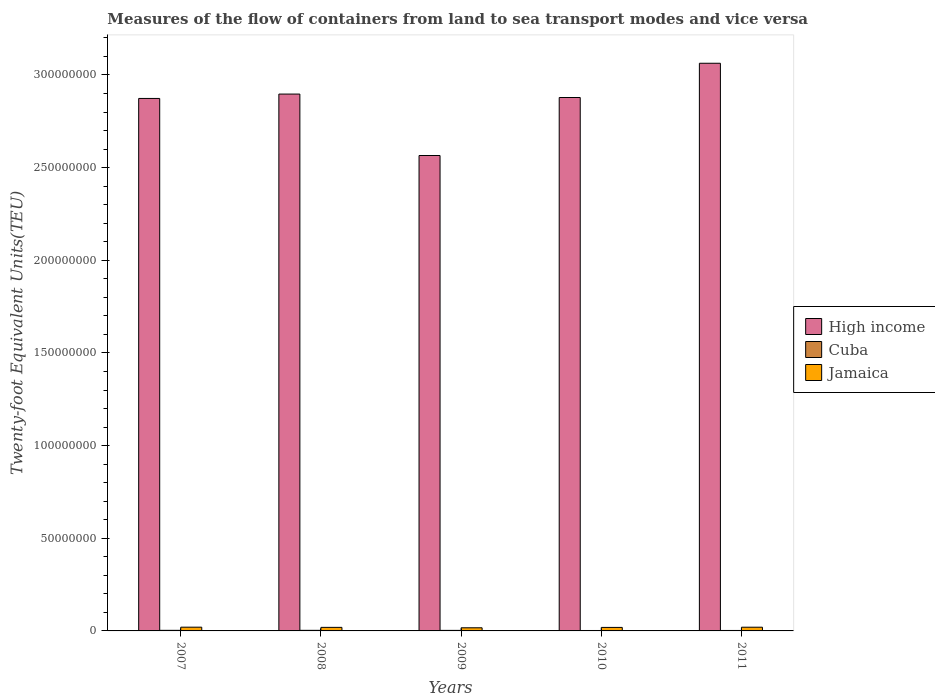How many bars are there on the 1st tick from the left?
Your answer should be very brief. 3. What is the label of the 4th group of bars from the left?
Make the answer very short. 2010. What is the container port traffic in High income in 2011?
Your answer should be compact. 3.06e+08. Across all years, what is the maximum container port traffic in High income?
Provide a succinct answer. 3.06e+08. Across all years, what is the minimum container port traffic in High income?
Make the answer very short. 2.57e+08. In which year was the container port traffic in Cuba maximum?
Offer a terse response. 2007. What is the total container port traffic in Cuba in the graph?
Offer a very short reply. 1.40e+06. What is the difference between the container port traffic in High income in 2007 and that in 2009?
Give a very brief answer. 3.08e+07. What is the difference between the container port traffic in Cuba in 2008 and the container port traffic in Jamaica in 2007?
Provide a succinct answer. -1.70e+06. What is the average container port traffic in Jamaica per year?
Provide a succinct answer. 1.90e+06. In the year 2011, what is the difference between the container port traffic in High income and container port traffic in Jamaica?
Provide a short and direct response. 3.04e+08. In how many years, is the container port traffic in Jamaica greater than 170000000 TEU?
Keep it short and to the point. 0. What is the ratio of the container port traffic in Jamaica in 2008 to that in 2011?
Your response must be concise. 0.96. What is the difference between the highest and the second highest container port traffic in Cuba?
Make the answer very short. 857. What is the difference between the highest and the lowest container port traffic in High income?
Make the answer very short. 4.98e+07. In how many years, is the container port traffic in Cuba greater than the average container port traffic in Cuba taken over all years?
Provide a short and direct response. 3. What does the 1st bar from the left in 2011 represents?
Offer a very short reply. High income. What does the 3rd bar from the right in 2007 represents?
Provide a succinct answer. High income. Is it the case that in every year, the sum of the container port traffic in High income and container port traffic in Jamaica is greater than the container port traffic in Cuba?
Your answer should be compact. Yes. How many bars are there?
Make the answer very short. 15. Does the graph contain grids?
Provide a succinct answer. No. Where does the legend appear in the graph?
Keep it short and to the point. Center right. How many legend labels are there?
Your answer should be very brief. 3. How are the legend labels stacked?
Offer a terse response. Vertical. What is the title of the graph?
Keep it short and to the point. Measures of the flow of containers from land to sea transport modes and vice versa. Does "Senegal" appear as one of the legend labels in the graph?
Offer a terse response. No. What is the label or title of the X-axis?
Your answer should be compact. Years. What is the label or title of the Y-axis?
Offer a terse response. Twenty-foot Equivalent Units(TEU). What is the Twenty-foot Equivalent Units(TEU) in High income in 2007?
Keep it short and to the point. 2.87e+08. What is the Twenty-foot Equivalent Units(TEU) of Cuba in 2007?
Provide a short and direct response. 3.20e+05. What is the Twenty-foot Equivalent Units(TEU) in Jamaica in 2007?
Offer a terse response. 2.02e+06. What is the Twenty-foot Equivalent Units(TEU) of High income in 2008?
Provide a short and direct response. 2.90e+08. What is the Twenty-foot Equivalent Units(TEU) in Cuba in 2008?
Your answer should be compact. 3.19e+05. What is the Twenty-foot Equivalent Units(TEU) of Jamaica in 2008?
Your response must be concise. 1.92e+06. What is the Twenty-foot Equivalent Units(TEU) in High income in 2009?
Keep it short and to the point. 2.57e+08. What is the Twenty-foot Equivalent Units(TEU) in Cuba in 2009?
Your answer should be compact. 2.90e+05. What is the Twenty-foot Equivalent Units(TEU) of Jamaica in 2009?
Ensure brevity in your answer.  1.69e+06. What is the Twenty-foot Equivalent Units(TEU) in High income in 2010?
Give a very brief answer. 2.88e+08. What is the Twenty-foot Equivalent Units(TEU) in Cuba in 2010?
Offer a very short reply. 2.28e+05. What is the Twenty-foot Equivalent Units(TEU) in Jamaica in 2010?
Ensure brevity in your answer.  1.89e+06. What is the Twenty-foot Equivalent Units(TEU) of High income in 2011?
Offer a very short reply. 3.06e+08. What is the Twenty-foot Equivalent Units(TEU) in Cuba in 2011?
Keep it short and to the point. 2.47e+05. What is the Twenty-foot Equivalent Units(TEU) in Jamaica in 2011?
Offer a very short reply. 2.00e+06. Across all years, what is the maximum Twenty-foot Equivalent Units(TEU) of High income?
Give a very brief answer. 3.06e+08. Across all years, what is the maximum Twenty-foot Equivalent Units(TEU) in Cuba?
Make the answer very short. 3.20e+05. Across all years, what is the maximum Twenty-foot Equivalent Units(TEU) in Jamaica?
Make the answer very short. 2.02e+06. Across all years, what is the minimum Twenty-foot Equivalent Units(TEU) in High income?
Provide a succinct answer. 2.57e+08. Across all years, what is the minimum Twenty-foot Equivalent Units(TEU) of Cuba?
Provide a short and direct response. 2.28e+05. Across all years, what is the minimum Twenty-foot Equivalent Units(TEU) of Jamaica?
Keep it short and to the point. 1.69e+06. What is the total Twenty-foot Equivalent Units(TEU) of High income in the graph?
Give a very brief answer. 1.43e+09. What is the total Twenty-foot Equivalent Units(TEU) of Cuba in the graph?
Keep it short and to the point. 1.40e+06. What is the total Twenty-foot Equivalent Units(TEU) of Jamaica in the graph?
Ensure brevity in your answer.  9.51e+06. What is the difference between the Twenty-foot Equivalent Units(TEU) in High income in 2007 and that in 2008?
Your answer should be compact. -2.36e+06. What is the difference between the Twenty-foot Equivalent Units(TEU) of Cuba in 2007 and that in 2008?
Provide a short and direct response. 857. What is the difference between the Twenty-foot Equivalent Units(TEU) of Jamaica in 2007 and that in 2008?
Your answer should be compact. 1.01e+05. What is the difference between the Twenty-foot Equivalent Units(TEU) of High income in 2007 and that in 2009?
Give a very brief answer. 3.08e+07. What is the difference between the Twenty-foot Equivalent Units(TEU) in Cuba in 2007 and that in 2009?
Your answer should be very brief. 2.98e+04. What is the difference between the Twenty-foot Equivalent Units(TEU) in Jamaica in 2007 and that in 2009?
Provide a succinct answer. 3.27e+05. What is the difference between the Twenty-foot Equivalent Units(TEU) of High income in 2007 and that in 2010?
Keep it short and to the point. -5.10e+05. What is the difference between the Twenty-foot Equivalent Units(TEU) of Cuba in 2007 and that in 2010?
Offer a very short reply. 9.15e+04. What is the difference between the Twenty-foot Equivalent Units(TEU) of Jamaica in 2007 and that in 2010?
Your answer should be very brief. 1.25e+05. What is the difference between the Twenty-foot Equivalent Units(TEU) in High income in 2007 and that in 2011?
Your response must be concise. -1.90e+07. What is the difference between the Twenty-foot Equivalent Units(TEU) in Cuba in 2007 and that in 2011?
Provide a succinct answer. 7.31e+04. What is the difference between the Twenty-foot Equivalent Units(TEU) of Jamaica in 2007 and that in 2011?
Make the answer very short. 1.72e+04. What is the difference between the Twenty-foot Equivalent Units(TEU) of High income in 2008 and that in 2009?
Keep it short and to the point. 3.32e+07. What is the difference between the Twenty-foot Equivalent Units(TEU) of Cuba in 2008 and that in 2009?
Keep it short and to the point. 2.89e+04. What is the difference between the Twenty-foot Equivalent Units(TEU) of Jamaica in 2008 and that in 2009?
Provide a succinct answer. 2.26e+05. What is the difference between the Twenty-foot Equivalent Units(TEU) in High income in 2008 and that in 2010?
Offer a very short reply. 1.85e+06. What is the difference between the Twenty-foot Equivalent Units(TEU) of Cuba in 2008 and that in 2010?
Provide a short and direct response. 9.07e+04. What is the difference between the Twenty-foot Equivalent Units(TEU) in Jamaica in 2008 and that in 2010?
Your answer should be very brief. 2.42e+04. What is the difference between the Twenty-foot Equivalent Units(TEU) in High income in 2008 and that in 2011?
Ensure brevity in your answer.  -1.66e+07. What is the difference between the Twenty-foot Equivalent Units(TEU) of Cuba in 2008 and that in 2011?
Provide a short and direct response. 7.22e+04. What is the difference between the Twenty-foot Equivalent Units(TEU) in Jamaica in 2008 and that in 2011?
Your answer should be very brief. -8.37e+04. What is the difference between the Twenty-foot Equivalent Units(TEU) of High income in 2009 and that in 2010?
Offer a very short reply. -3.13e+07. What is the difference between the Twenty-foot Equivalent Units(TEU) of Cuba in 2009 and that in 2010?
Your answer should be compact. 6.18e+04. What is the difference between the Twenty-foot Equivalent Units(TEU) in Jamaica in 2009 and that in 2010?
Make the answer very short. -2.02e+05. What is the difference between the Twenty-foot Equivalent Units(TEU) of High income in 2009 and that in 2011?
Your answer should be very brief. -4.98e+07. What is the difference between the Twenty-foot Equivalent Units(TEU) of Cuba in 2009 and that in 2011?
Ensure brevity in your answer.  4.33e+04. What is the difference between the Twenty-foot Equivalent Units(TEU) in Jamaica in 2009 and that in 2011?
Make the answer very short. -3.10e+05. What is the difference between the Twenty-foot Equivalent Units(TEU) of High income in 2010 and that in 2011?
Ensure brevity in your answer.  -1.85e+07. What is the difference between the Twenty-foot Equivalent Units(TEU) of Cuba in 2010 and that in 2011?
Your response must be concise. -1.84e+04. What is the difference between the Twenty-foot Equivalent Units(TEU) in Jamaica in 2010 and that in 2011?
Your answer should be compact. -1.08e+05. What is the difference between the Twenty-foot Equivalent Units(TEU) of High income in 2007 and the Twenty-foot Equivalent Units(TEU) of Cuba in 2008?
Give a very brief answer. 2.87e+08. What is the difference between the Twenty-foot Equivalent Units(TEU) of High income in 2007 and the Twenty-foot Equivalent Units(TEU) of Jamaica in 2008?
Ensure brevity in your answer.  2.85e+08. What is the difference between the Twenty-foot Equivalent Units(TEU) of Cuba in 2007 and the Twenty-foot Equivalent Units(TEU) of Jamaica in 2008?
Provide a short and direct response. -1.60e+06. What is the difference between the Twenty-foot Equivalent Units(TEU) in High income in 2007 and the Twenty-foot Equivalent Units(TEU) in Cuba in 2009?
Offer a very short reply. 2.87e+08. What is the difference between the Twenty-foot Equivalent Units(TEU) in High income in 2007 and the Twenty-foot Equivalent Units(TEU) in Jamaica in 2009?
Keep it short and to the point. 2.86e+08. What is the difference between the Twenty-foot Equivalent Units(TEU) in Cuba in 2007 and the Twenty-foot Equivalent Units(TEU) in Jamaica in 2009?
Your answer should be very brief. -1.37e+06. What is the difference between the Twenty-foot Equivalent Units(TEU) of High income in 2007 and the Twenty-foot Equivalent Units(TEU) of Cuba in 2010?
Give a very brief answer. 2.87e+08. What is the difference between the Twenty-foot Equivalent Units(TEU) in High income in 2007 and the Twenty-foot Equivalent Units(TEU) in Jamaica in 2010?
Offer a terse response. 2.85e+08. What is the difference between the Twenty-foot Equivalent Units(TEU) in Cuba in 2007 and the Twenty-foot Equivalent Units(TEU) in Jamaica in 2010?
Make the answer very short. -1.57e+06. What is the difference between the Twenty-foot Equivalent Units(TEU) in High income in 2007 and the Twenty-foot Equivalent Units(TEU) in Cuba in 2011?
Your answer should be compact. 2.87e+08. What is the difference between the Twenty-foot Equivalent Units(TEU) in High income in 2007 and the Twenty-foot Equivalent Units(TEU) in Jamaica in 2011?
Offer a terse response. 2.85e+08. What is the difference between the Twenty-foot Equivalent Units(TEU) of Cuba in 2007 and the Twenty-foot Equivalent Units(TEU) of Jamaica in 2011?
Provide a succinct answer. -1.68e+06. What is the difference between the Twenty-foot Equivalent Units(TEU) in High income in 2008 and the Twenty-foot Equivalent Units(TEU) in Cuba in 2009?
Provide a succinct answer. 2.89e+08. What is the difference between the Twenty-foot Equivalent Units(TEU) in High income in 2008 and the Twenty-foot Equivalent Units(TEU) in Jamaica in 2009?
Offer a terse response. 2.88e+08. What is the difference between the Twenty-foot Equivalent Units(TEU) in Cuba in 2008 and the Twenty-foot Equivalent Units(TEU) in Jamaica in 2009?
Keep it short and to the point. -1.37e+06. What is the difference between the Twenty-foot Equivalent Units(TEU) of High income in 2008 and the Twenty-foot Equivalent Units(TEU) of Cuba in 2010?
Provide a short and direct response. 2.89e+08. What is the difference between the Twenty-foot Equivalent Units(TEU) in High income in 2008 and the Twenty-foot Equivalent Units(TEU) in Jamaica in 2010?
Provide a short and direct response. 2.88e+08. What is the difference between the Twenty-foot Equivalent Units(TEU) of Cuba in 2008 and the Twenty-foot Equivalent Units(TEU) of Jamaica in 2010?
Your response must be concise. -1.57e+06. What is the difference between the Twenty-foot Equivalent Units(TEU) in High income in 2008 and the Twenty-foot Equivalent Units(TEU) in Cuba in 2011?
Your answer should be compact. 2.89e+08. What is the difference between the Twenty-foot Equivalent Units(TEU) in High income in 2008 and the Twenty-foot Equivalent Units(TEU) in Jamaica in 2011?
Your answer should be very brief. 2.88e+08. What is the difference between the Twenty-foot Equivalent Units(TEU) in Cuba in 2008 and the Twenty-foot Equivalent Units(TEU) in Jamaica in 2011?
Offer a very short reply. -1.68e+06. What is the difference between the Twenty-foot Equivalent Units(TEU) of High income in 2009 and the Twenty-foot Equivalent Units(TEU) of Cuba in 2010?
Keep it short and to the point. 2.56e+08. What is the difference between the Twenty-foot Equivalent Units(TEU) of High income in 2009 and the Twenty-foot Equivalent Units(TEU) of Jamaica in 2010?
Offer a terse response. 2.55e+08. What is the difference between the Twenty-foot Equivalent Units(TEU) in Cuba in 2009 and the Twenty-foot Equivalent Units(TEU) in Jamaica in 2010?
Offer a terse response. -1.60e+06. What is the difference between the Twenty-foot Equivalent Units(TEU) of High income in 2009 and the Twenty-foot Equivalent Units(TEU) of Cuba in 2011?
Provide a succinct answer. 2.56e+08. What is the difference between the Twenty-foot Equivalent Units(TEU) in High income in 2009 and the Twenty-foot Equivalent Units(TEU) in Jamaica in 2011?
Your response must be concise. 2.55e+08. What is the difference between the Twenty-foot Equivalent Units(TEU) of Cuba in 2009 and the Twenty-foot Equivalent Units(TEU) of Jamaica in 2011?
Keep it short and to the point. -1.71e+06. What is the difference between the Twenty-foot Equivalent Units(TEU) of High income in 2010 and the Twenty-foot Equivalent Units(TEU) of Cuba in 2011?
Provide a succinct answer. 2.88e+08. What is the difference between the Twenty-foot Equivalent Units(TEU) in High income in 2010 and the Twenty-foot Equivalent Units(TEU) in Jamaica in 2011?
Keep it short and to the point. 2.86e+08. What is the difference between the Twenty-foot Equivalent Units(TEU) of Cuba in 2010 and the Twenty-foot Equivalent Units(TEU) of Jamaica in 2011?
Ensure brevity in your answer.  -1.77e+06. What is the average Twenty-foot Equivalent Units(TEU) of High income per year?
Offer a very short reply. 2.86e+08. What is the average Twenty-foot Equivalent Units(TEU) in Cuba per year?
Make the answer very short. 2.81e+05. What is the average Twenty-foot Equivalent Units(TEU) of Jamaica per year?
Offer a terse response. 1.90e+06. In the year 2007, what is the difference between the Twenty-foot Equivalent Units(TEU) of High income and Twenty-foot Equivalent Units(TEU) of Cuba?
Provide a short and direct response. 2.87e+08. In the year 2007, what is the difference between the Twenty-foot Equivalent Units(TEU) in High income and Twenty-foot Equivalent Units(TEU) in Jamaica?
Your answer should be compact. 2.85e+08. In the year 2007, what is the difference between the Twenty-foot Equivalent Units(TEU) in Cuba and Twenty-foot Equivalent Units(TEU) in Jamaica?
Give a very brief answer. -1.70e+06. In the year 2008, what is the difference between the Twenty-foot Equivalent Units(TEU) of High income and Twenty-foot Equivalent Units(TEU) of Cuba?
Provide a short and direct response. 2.89e+08. In the year 2008, what is the difference between the Twenty-foot Equivalent Units(TEU) in High income and Twenty-foot Equivalent Units(TEU) in Jamaica?
Your answer should be compact. 2.88e+08. In the year 2008, what is the difference between the Twenty-foot Equivalent Units(TEU) of Cuba and Twenty-foot Equivalent Units(TEU) of Jamaica?
Provide a succinct answer. -1.60e+06. In the year 2009, what is the difference between the Twenty-foot Equivalent Units(TEU) of High income and Twenty-foot Equivalent Units(TEU) of Cuba?
Your answer should be compact. 2.56e+08. In the year 2009, what is the difference between the Twenty-foot Equivalent Units(TEU) in High income and Twenty-foot Equivalent Units(TEU) in Jamaica?
Give a very brief answer. 2.55e+08. In the year 2009, what is the difference between the Twenty-foot Equivalent Units(TEU) of Cuba and Twenty-foot Equivalent Units(TEU) of Jamaica?
Give a very brief answer. -1.40e+06. In the year 2010, what is the difference between the Twenty-foot Equivalent Units(TEU) in High income and Twenty-foot Equivalent Units(TEU) in Cuba?
Make the answer very short. 2.88e+08. In the year 2010, what is the difference between the Twenty-foot Equivalent Units(TEU) in High income and Twenty-foot Equivalent Units(TEU) in Jamaica?
Keep it short and to the point. 2.86e+08. In the year 2010, what is the difference between the Twenty-foot Equivalent Units(TEU) in Cuba and Twenty-foot Equivalent Units(TEU) in Jamaica?
Your answer should be compact. -1.66e+06. In the year 2011, what is the difference between the Twenty-foot Equivalent Units(TEU) in High income and Twenty-foot Equivalent Units(TEU) in Cuba?
Your response must be concise. 3.06e+08. In the year 2011, what is the difference between the Twenty-foot Equivalent Units(TEU) of High income and Twenty-foot Equivalent Units(TEU) of Jamaica?
Your response must be concise. 3.04e+08. In the year 2011, what is the difference between the Twenty-foot Equivalent Units(TEU) of Cuba and Twenty-foot Equivalent Units(TEU) of Jamaica?
Provide a short and direct response. -1.75e+06. What is the ratio of the Twenty-foot Equivalent Units(TEU) of Cuba in 2007 to that in 2008?
Keep it short and to the point. 1. What is the ratio of the Twenty-foot Equivalent Units(TEU) in Jamaica in 2007 to that in 2008?
Provide a short and direct response. 1.05. What is the ratio of the Twenty-foot Equivalent Units(TEU) in High income in 2007 to that in 2009?
Provide a short and direct response. 1.12. What is the ratio of the Twenty-foot Equivalent Units(TEU) of Cuba in 2007 to that in 2009?
Your response must be concise. 1.1. What is the ratio of the Twenty-foot Equivalent Units(TEU) of Jamaica in 2007 to that in 2009?
Your response must be concise. 1.19. What is the ratio of the Twenty-foot Equivalent Units(TEU) in High income in 2007 to that in 2010?
Provide a succinct answer. 1. What is the ratio of the Twenty-foot Equivalent Units(TEU) of Cuba in 2007 to that in 2010?
Provide a short and direct response. 1.4. What is the ratio of the Twenty-foot Equivalent Units(TEU) of Jamaica in 2007 to that in 2010?
Keep it short and to the point. 1.07. What is the ratio of the Twenty-foot Equivalent Units(TEU) in High income in 2007 to that in 2011?
Offer a very short reply. 0.94. What is the ratio of the Twenty-foot Equivalent Units(TEU) of Cuba in 2007 to that in 2011?
Provide a succinct answer. 1.3. What is the ratio of the Twenty-foot Equivalent Units(TEU) in Jamaica in 2007 to that in 2011?
Keep it short and to the point. 1.01. What is the ratio of the Twenty-foot Equivalent Units(TEU) of High income in 2008 to that in 2009?
Your answer should be very brief. 1.13. What is the ratio of the Twenty-foot Equivalent Units(TEU) of Cuba in 2008 to that in 2009?
Your answer should be very brief. 1.1. What is the ratio of the Twenty-foot Equivalent Units(TEU) of Jamaica in 2008 to that in 2009?
Provide a succinct answer. 1.13. What is the ratio of the Twenty-foot Equivalent Units(TEU) of High income in 2008 to that in 2010?
Your answer should be compact. 1.01. What is the ratio of the Twenty-foot Equivalent Units(TEU) of Cuba in 2008 to that in 2010?
Provide a succinct answer. 1.4. What is the ratio of the Twenty-foot Equivalent Units(TEU) of Jamaica in 2008 to that in 2010?
Offer a very short reply. 1.01. What is the ratio of the Twenty-foot Equivalent Units(TEU) of High income in 2008 to that in 2011?
Offer a very short reply. 0.95. What is the ratio of the Twenty-foot Equivalent Units(TEU) in Cuba in 2008 to that in 2011?
Ensure brevity in your answer.  1.29. What is the ratio of the Twenty-foot Equivalent Units(TEU) of Jamaica in 2008 to that in 2011?
Your answer should be very brief. 0.96. What is the ratio of the Twenty-foot Equivalent Units(TEU) in High income in 2009 to that in 2010?
Keep it short and to the point. 0.89. What is the ratio of the Twenty-foot Equivalent Units(TEU) in Cuba in 2009 to that in 2010?
Provide a succinct answer. 1.27. What is the ratio of the Twenty-foot Equivalent Units(TEU) in Jamaica in 2009 to that in 2010?
Your answer should be very brief. 0.89. What is the ratio of the Twenty-foot Equivalent Units(TEU) in High income in 2009 to that in 2011?
Give a very brief answer. 0.84. What is the ratio of the Twenty-foot Equivalent Units(TEU) of Cuba in 2009 to that in 2011?
Offer a very short reply. 1.18. What is the ratio of the Twenty-foot Equivalent Units(TEU) of Jamaica in 2009 to that in 2011?
Make the answer very short. 0.84. What is the ratio of the Twenty-foot Equivalent Units(TEU) in High income in 2010 to that in 2011?
Offer a terse response. 0.94. What is the ratio of the Twenty-foot Equivalent Units(TEU) in Cuba in 2010 to that in 2011?
Provide a short and direct response. 0.93. What is the ratio of the Twenty-foot Equivalent Units(TEU) of Jamaica in 2010 to that in 2011?
Your answer should be compact. 0.95. What is the difference between the highest and the second highest Twenty-foot Equivalent Units(TEU) of High income?
Your answer should be very brief. 1.66e+07. What is the difference between the highest and the second highest Twenty-foot Equivalent Units(TEU) in Cuba?
Your response must be concise. 857. What is the difference between the highest and the second highest Twenty-foot Equivalent Units(TEU) of Jamaica?
Ensure brevity in your answer.  1.72e+04. What is the difference between the highest and the lowest Twenty-foot Equivalent Units(TEU) in High income?
Ensure brevity in your answer.  4.98e+07. What is the difference between the highest and the lowest Twenty-foot Equivalent Units(TEU) in Cuba?
Provide a succinct answer. 9.15e+04. What is the difference between the highest and the lowest Twenty-foot Equivalent Units(TEU) of Jamaica?
Ensure brevity in your answer.  3.27e+05. 